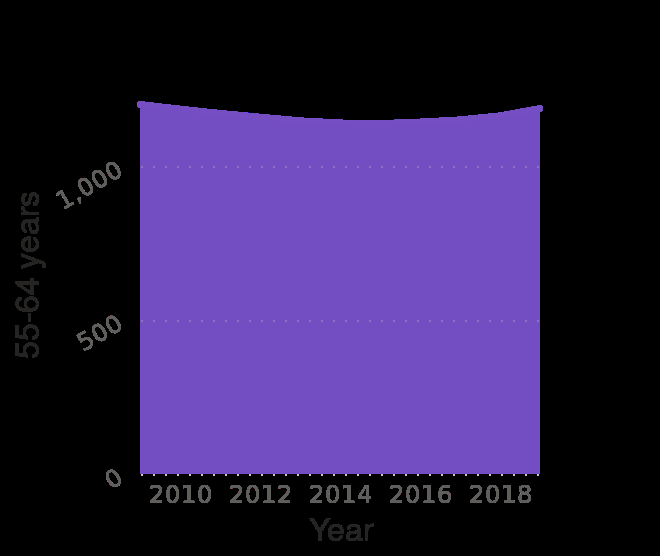<image>
What is the data range covered by the area plot? The area plot covers the period from 2009 to 2019. Can the trend in the number of Swedish people aged 55-64 be described as continuous? Yes, the trend in the number of Swedish people aged 55-64 can be described as relatively continuous, with a small dip and subsequent increase. 